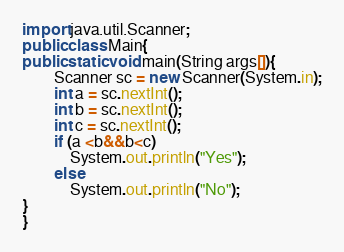<code> <loc_0><loc_0><loc_500><loc_500><_Java_>import java.util.Scanner;
public class Main{
public static void main(String args[]){
        Scanner sc = new Scanner(System.in);
        int a = sc.nextInt();
        int b = sc.nextInt();
        int c = sc.nextInt();
        if (a <b&&b<c)
            System.out.println("Yes");
        else
            System.out.println("No");
}
}
</code> 